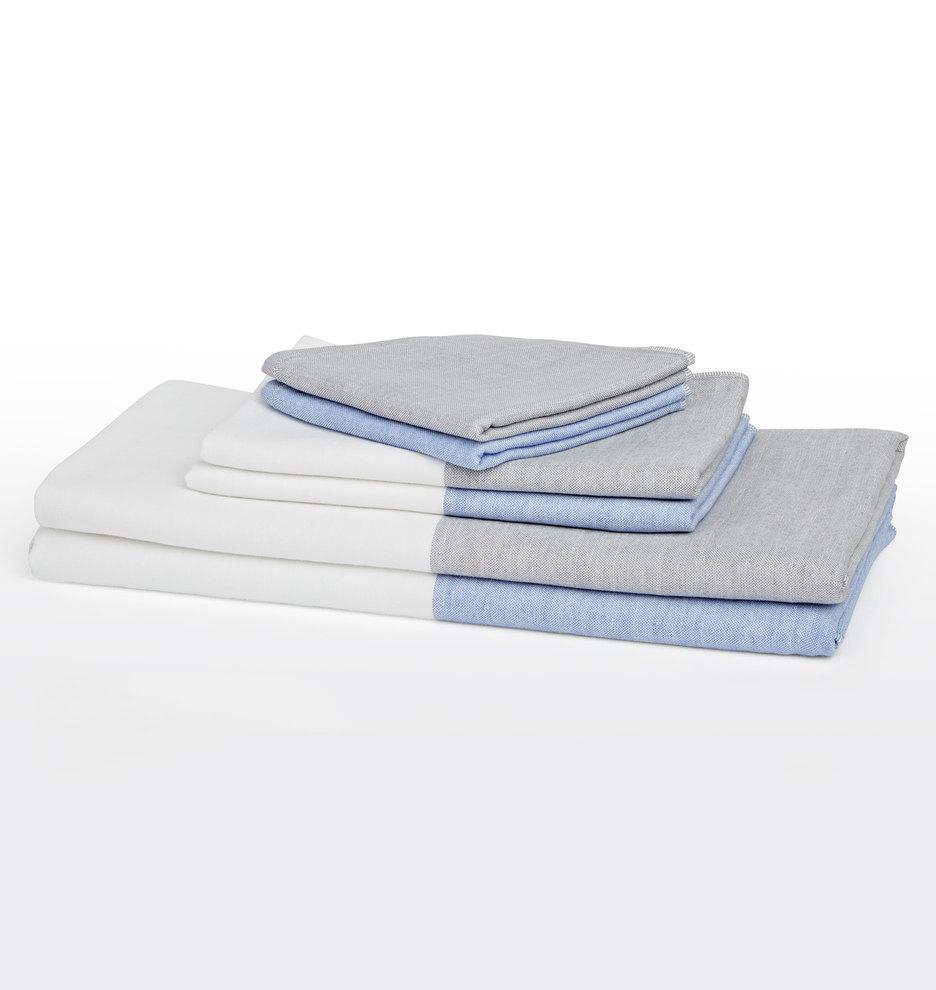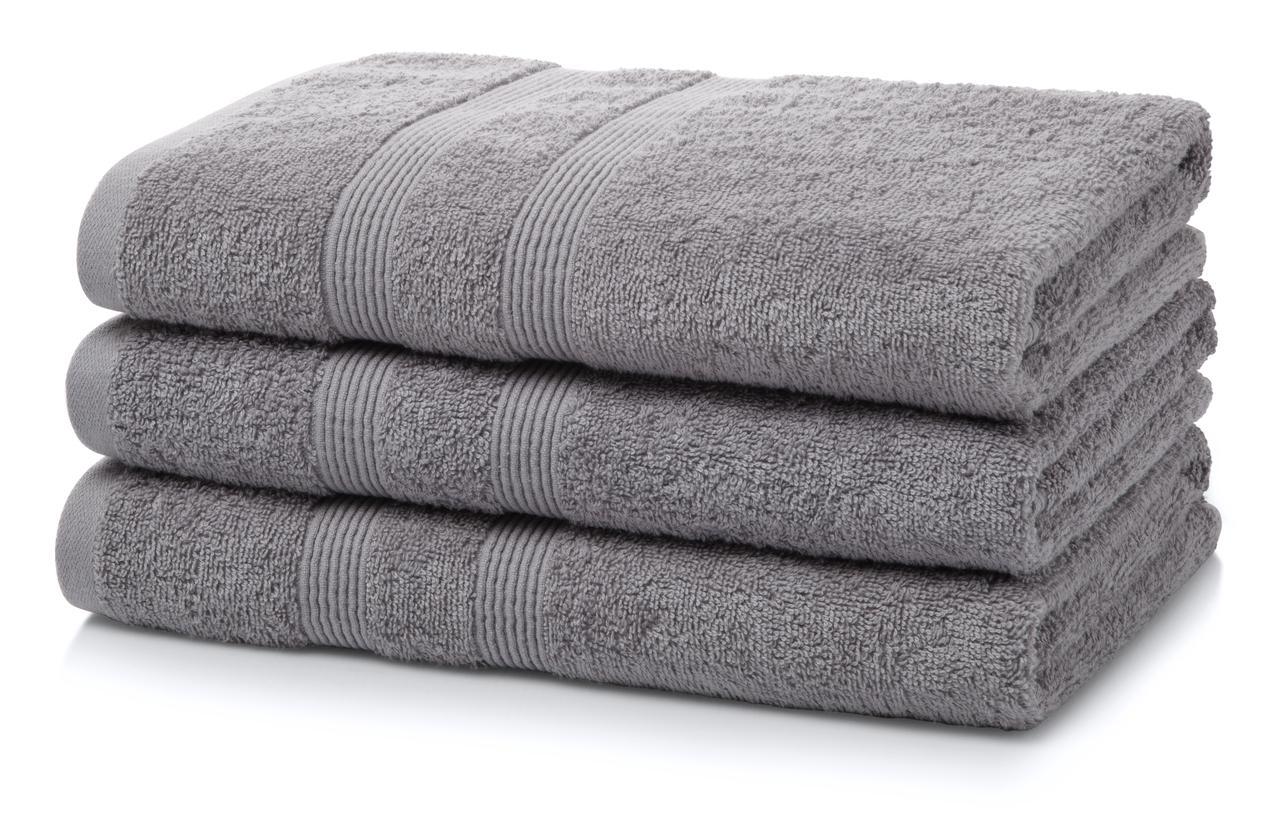The first image is the image on the left, the second image is the image on the right. Analyze the images presented: Is the assertion "An image shows a stack of at least two solid gray towels." valid? Answer yes or no. Yes. 